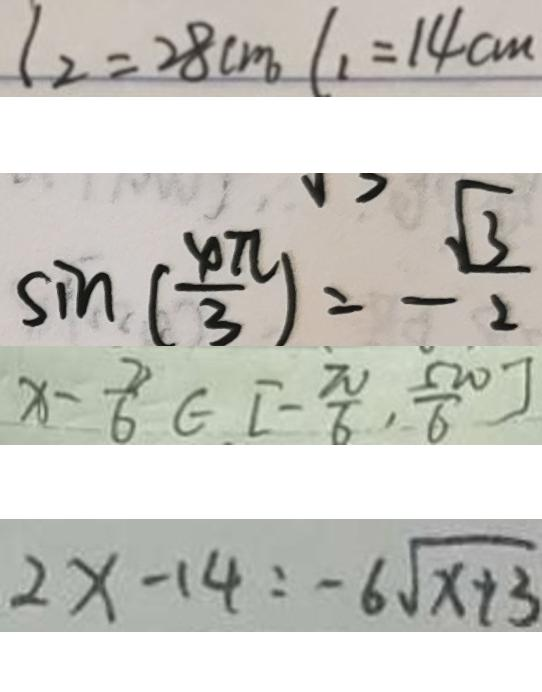<formula> <loc_0><loc_0><loc_500><loc_500>l _ { 2 } = 2 8 c m l _ { 1 } = 1 4 c m 
 \sin ( \frac { \varphi \pi } { 3 } ) = - \frac { \sqrt { 3 } } { 2 } 
 x - \frac { 2 } { 6 } \in [ - \frac { \pi } { 6 } , \frac { 5 \pi } { 6 } ] 
 2 x - 1 4 : - 6 \sqrt { x + 3 }</formula> 